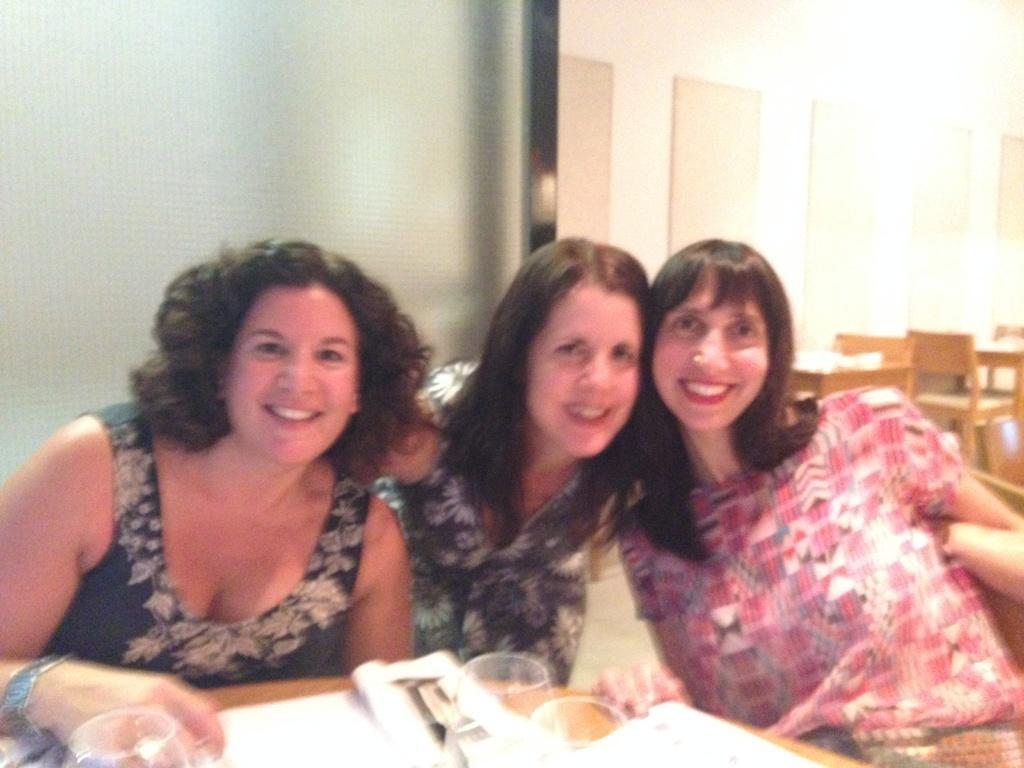In one or two sentences, can you explain what this image depicts? In this image I can see the people sitting in -front of the table. These people are wearing the different color dresses and they are smiling. On the table I can see some papers and glasses. In the back there are few more tables and chairs. And I can also see the white background. 